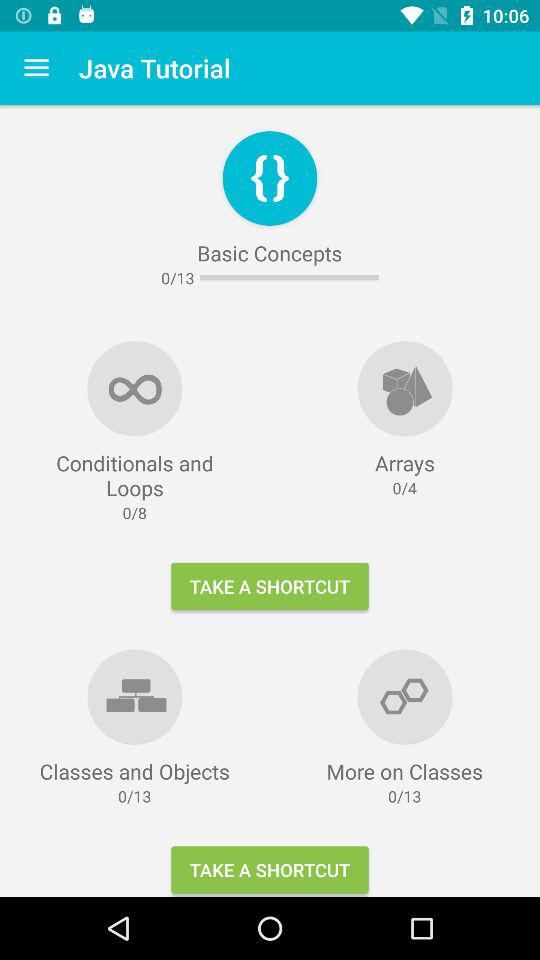How many modules in total are there in "Arrays" in "Java Tutorial"? There are 4 modules in total in "Arrays" in "Java Tutorial". 